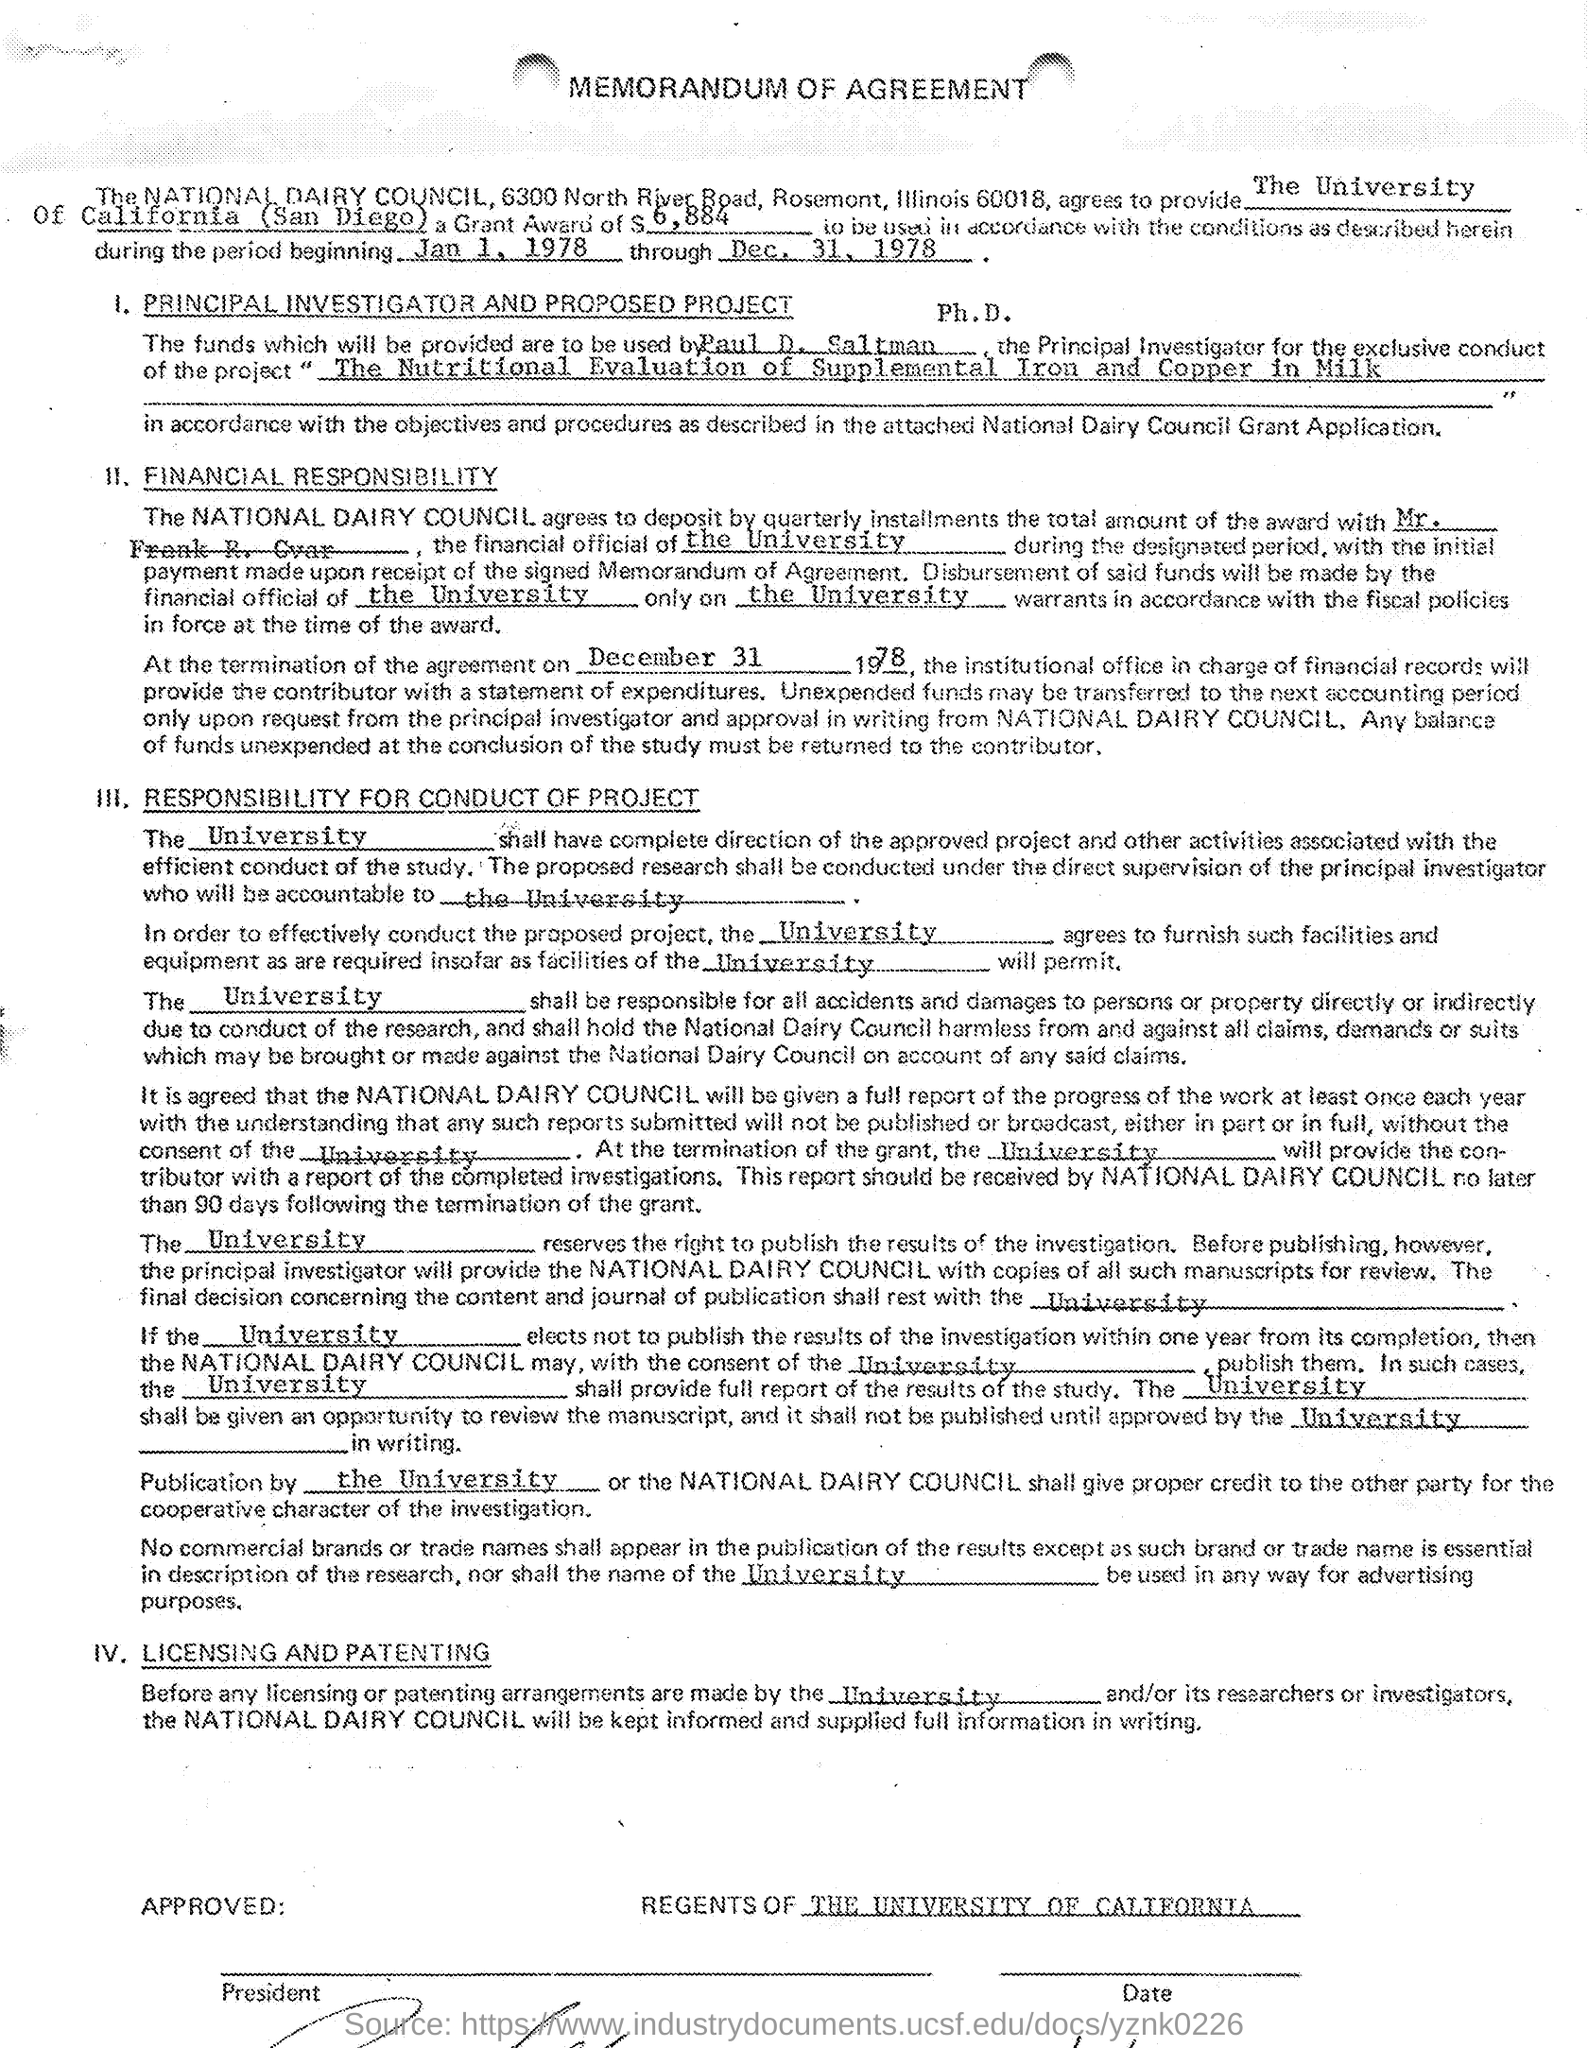Outline some significant characteristics in this image. The total amount awarded is $6,884. The project referred to in the question is called "The Nutritional Evaluation of Supplemental Iron and Copper in Milk. The funds can be used from January 1, 1978 until December 31, 1978. 